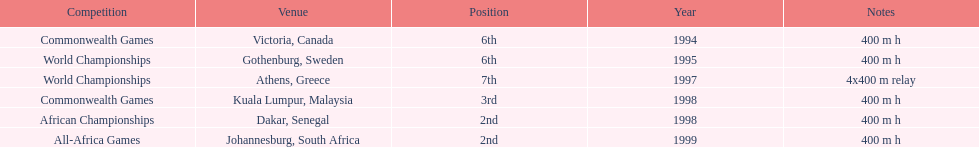What is the total number of competitions on this chart? 6. 